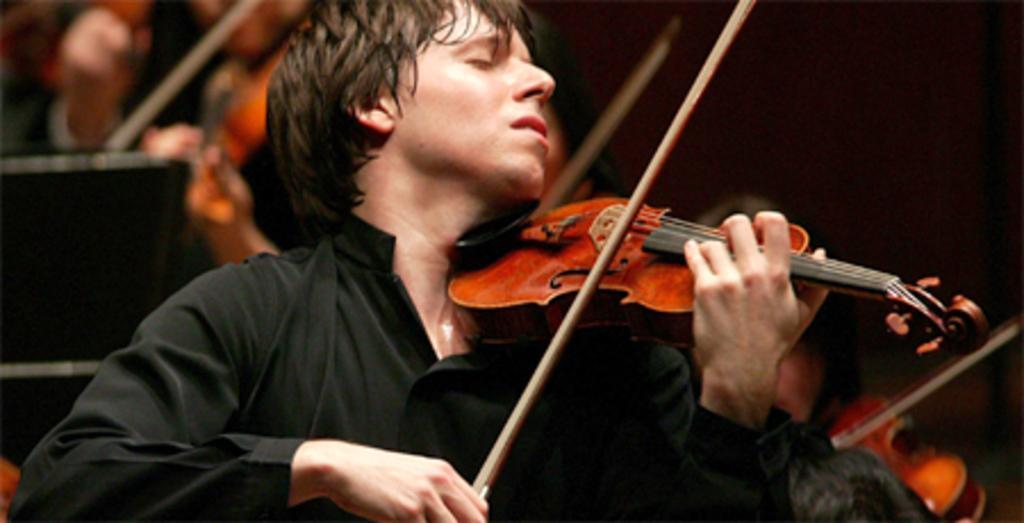Could you give a brief overview of what you see in this image? In the image their is a man who is playing a violin with his hand. At the background there are other people also who are playing a violin. 